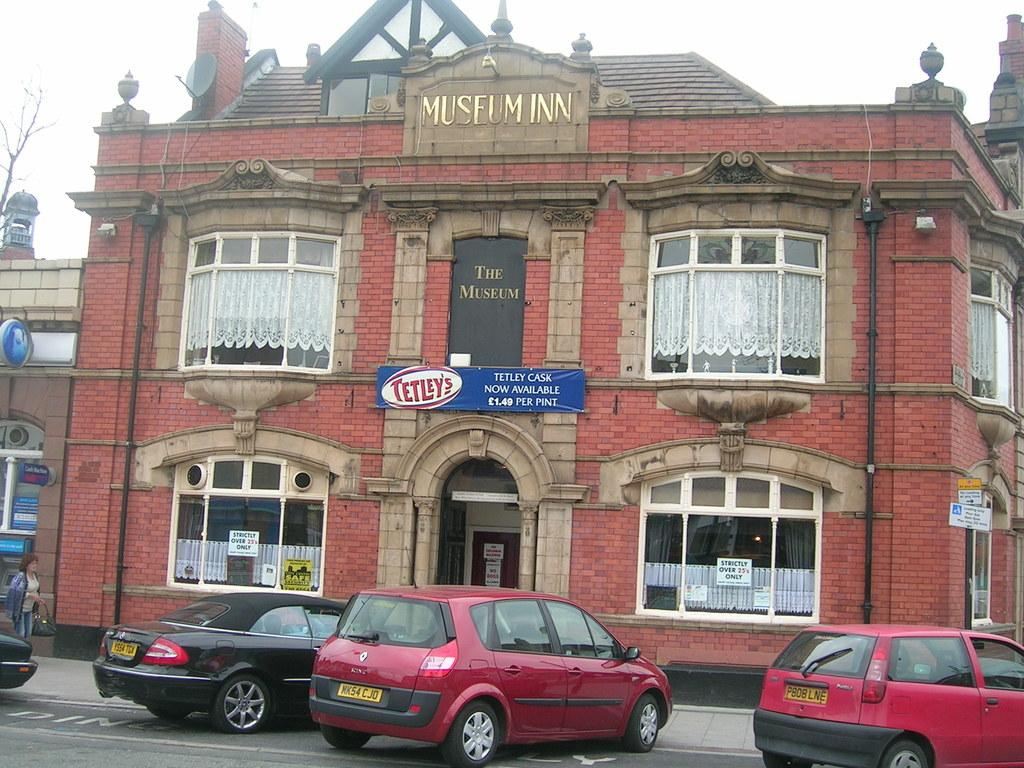What type of structure is visible in the image? There is a building in the image. What can be seen in front of the building? Cars are present on the road in front of the building. What is the condition of the tree on the left side of the image? There is a dry tree on the left side of the image. How does the secretary express anger in the image? There is no secretary present in the image, so it is not possible to determine how they might express anger. 